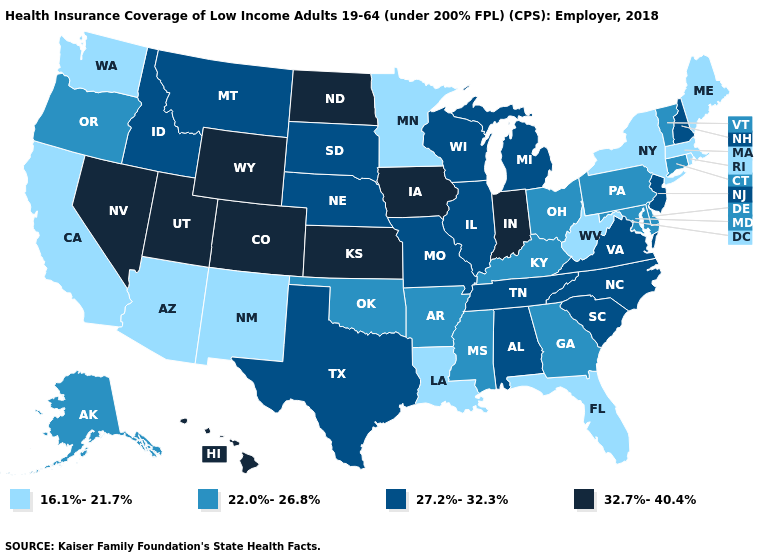Does Vermont have the same value as North Carolina?
Write a very short answer. No. Name the states that have a value in the range 22.0%-26.8%?
Give a very brief answer. Alaska, Arkansas, Connecticut, Delaware, Georgia, Kentucky, Maryland, Mississippi, Ohio, Oklahoma, Oregon, Pennsylvania, Vermont. Does the map have missing data?
Quick response, please. No. Name the states that have a value in the range 22.0%-26.8%?
Write a very short answer. Alaska, Arkansas, Connecticut, Delaware, Georgia, Kentucky, Maryland, Mississippi, Ohio, Oklahoma, Oregon, Pennsylvania, Vermont. Is the legend a continuous bar?
Concise answer only. No. Does Tennessee have a lower value than Indiana?
Keep it brief. Yes. Does the map have missing data?
Keep it brief. No. Name the states that have a value in the range 22.0%-26.8%?
Quick response, please. Alaska, Arkansas, Connecticut, Delaware, Georgia, Kentucky, Maryland, Mississippi, Ohio, Oklahoma, Oregon, Pennsylvania, Vermont. Does the map have missing data?
Give a very brief answer. No. Among the states that border Arkansas , which have the highest value?
Give a very brief answer. Missouri, Tennessee, Texas. What is the value of Minnesota?
Quick response, please. 16.1%-21.7%. How many symbols are there in the legend?
Write a very short answer. 4. Name the states that have a value in the range 22.0%-26.8%?
Concise answer only. Alaska, Arkansas, Connecticut, Delaware, Georgia, Kentucky, Maryland, Mississippi, Ohio, Oklahoma, Oregon, Pennsylvania, Vermont. Does the first symbol in the legend represent the smallest category?
Answer briefly. Yes. Which states hav the highest value in the South?
Quick response, please. Alabama, North Carolina, South Carolina, Tennessee, Texas, Virginia. 